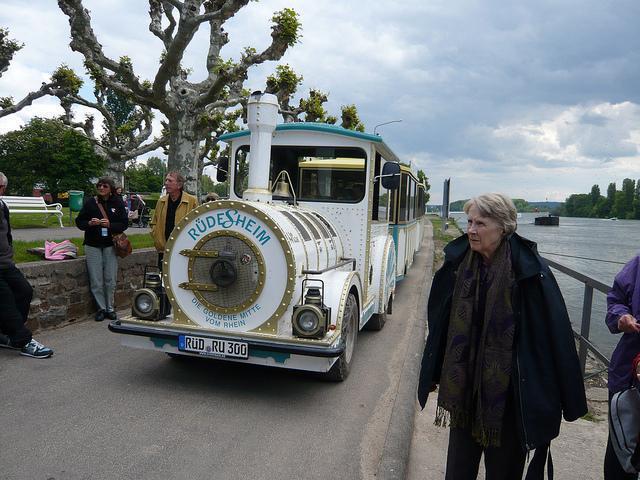How many people are there?
Give a very brief answer. 4. How many giraffes have their head down?
Give a very brief answer. 0. 